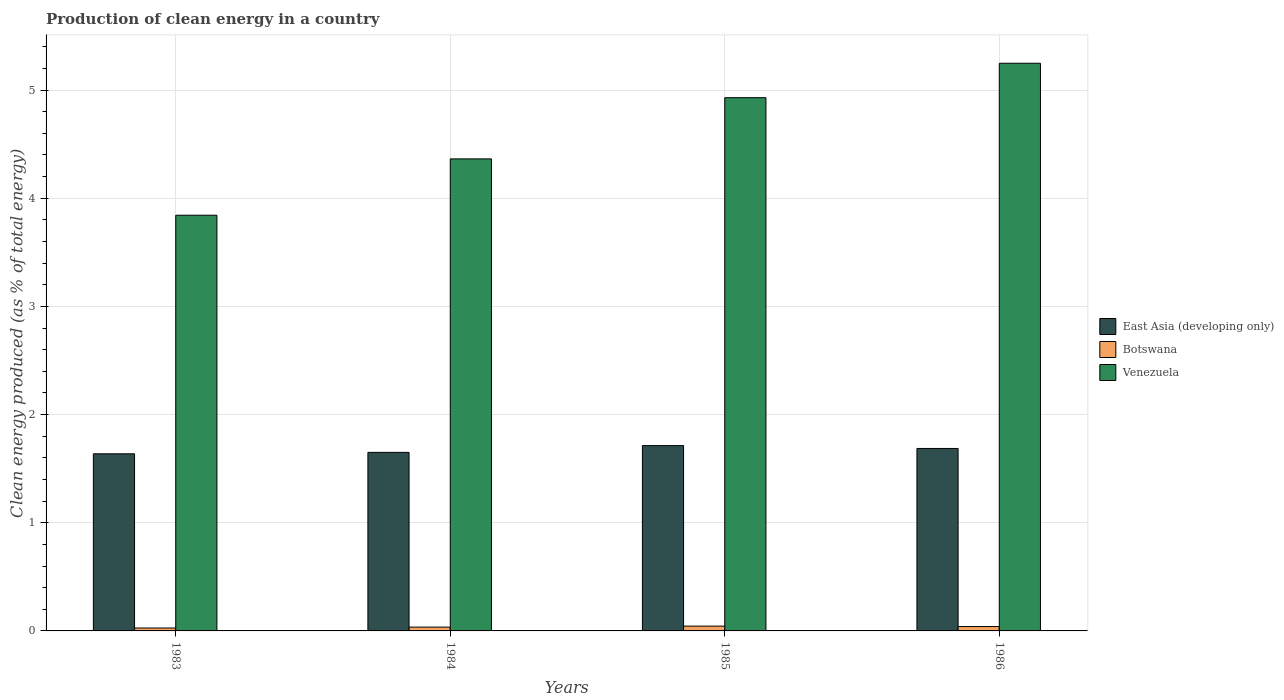How many different coloured bars are there?
Make the answer very short. 3. How many groups of bars are there?
Make the answer very short. 4. What is the label of the 3rd group of bars from the left?
Offer a terse response. 1985. In how many cases, is the number of bars for a given year not equal to the number of legend labels?
Offer a terse response. 0. What is the percentage of clean energy produced in Venezuela in 1986?
Make the answer very short. 5.25. Across all years, what is the maximum percentage of clean energy produced in East Asia (developing only)?
Your answer should be very brief. 1.71. Across all years, what is the minimum percentage of clean energy produced in Botswana?
Ensure brevity in your answer.  0.03. What is the total percentage of clean energy produced in East Asia (developing only) in the graph?
Keep it short and to the point. 6.69. What is the difference between the percentage of clean energy produced in Botswana in 1983 and that in 1985?
Offer a very short reply. -0.02. What is the difference between the percentage of clean energy produced in East Asia (developing only) in 1986 and the percentage of clean energy produced in Venezuela in 1984?
Give a very brief answer. -2.68. What is the average percentage of clean energy produced in Botswana per year?
Your response must be concise. 0.04. In the year 1986, what is the difference between the percentage of clean energy produced in Venezuela and percentage of clean energy produced in Botswana?
Your response must be concise. 5.21. In how many years, is the percentage of clean energy produced in East Asia (developing only) greater than 2.8 %?
Offer a terse response. 0. What is the ratio of the percentage of clean energy produced in East Asia (developing only) in 1984 to that in 1985?
Offer a very short reply. 0.96. Is the percentage of clean energy produced in Botswana in 1983 less than that in 1985?
Provide a short and direct response. Yes. What is the difference between the highest and the second highest percentage of clean energy produced in Venezuela?
Your answer should be compact. 0.32. What is the difference between the highest and the lowest percentage of clean energy produced in East Asia (developing only)?
Make the answer very short. 0.08. In how many years, is the percentage of clean energy produced in East Asia (developing only) greater than the average percentage of clean energy produced in East Asia (developing only) taken over all years?
Your answer should be compact. 2. Is the sum of the percentage of clean energy produced in Botswana in 1983 and 1985 greater than the maximum percentage of clean energy produced in East Asia (developing only) across all years?
Your answer should be compact. No. What does the 2nd bar from the left in 1983 represents?
Keep it short and to the point. Botswana. What does the 2nd bar from the right in 1984 represents?
Offer a very short reply. Botswana. Are all the bars in the graph horizontal?
Your response must be concise. No. How many years are there in the graph?
Offer a terse response. 4. What is the difference between two consecutive major ticks on the Y-axis?
Offer a very short reply. 1. Are the values on the major ticks of Y-axis written in scientific E-notation?
Provide a short and direct response. No. Where does the legend appear in the graph?
Your response must be concise. Center right. What is the title of the graph?
Give a very brief answer. Production of clean energy in a country. Does "Mongolia" appear as one of the legend labels in the graph?
Ensure brevity in your answer.  No. What is the label or title of the Y-axis?
Offer a terse response. Clean energy produced (as % of total energy). What is the Clean energy produced (as % of total energy) in East Asia (developing only) in 1983?
Offer a very short reply. 1.64. What is the Clean energy produced (as % of total energy) in Botswana in 1983?
Provide a short and direct response. 0.03. What is the Clean energy produced (as % of total energy) in Venezuela in 1983?
Offer a very short reply. 3.84. What is the Clean energy produced (as % of total energy) of East Asia (developing only) in 1984?
Your answer should be compact. 1.65. What is the Clean energy produced (as % of total energy) in Botswana in 1984?
Give a very brief answer. 0.04. What is the Clean energy produced (as % of total energy) in Venezuela in 1984?
Offer a terse response. 4.36. What is the Clean energy produced (as % of total energy) of East Asia (developing only) in 1985?
Ensure brevity in your answer.  1.71. What is the Clean energy produced (as % of total energy) of Botswana in 1985?
Make the answer very short. 0.04. What is the Clean energy produced (as % of total energy) of Venezuela in 1985?
Provide a short and direct response. 4.93. What is the Clean energy produced (as % of total energy) of East Asia (developing only) in 1986?
Ensure brevity in your answer.  1.69. What is the Clean energy produced (as % of total energy) in Botswana in 1986?
Offer a terse response. 0.04. What is the Clean energy produced (as % of total energy) in Venezuela in 1986?
Make the answer very short. 5.25. Across all years, what is the maximum Clean energy produced (as % of total energy) in East Asia (developing only)?
Your answer should be compact. 1.71. Across all years, what is the maximum Clean energy produced (as % of total energy) in Botswana?
Your response must be concise. 0.04. Across all years, what is the maximum Clean energy produced (as % of total energy) of Venezuela?
Your answer should be compact. 5.25. Across all years, what is the minimum Clean energy produced (as % of total energy) of East Asia (developing only)?
Your answer should be very brief. 1.64. Across all years, what is the minimum Clean energy produced (as % of total energy) of Botswana?
Your response must be concise. 0.03. Across all years, what is the minimum Clean energy produced (as % of total energy) of Venezuela?
Ensure brevity in your answer.  3.84. What is the total Clean energy produced (as % of total energy) of East Asia (developing only) in the graph?
Your answer should be very brief. 6.69. What is the total Clean energy produced (as % of total energy) of Botswana in the graph?
Your answer should be compact. 0.15. What is the total Clean energy produced (as % of total energy) of Venezuela in the graph?
Your answer should be compact. 18.38. What is the difference between the Clean energy produced (as % of total energy) of East Asia (developing only) in 1983 and that in 1984?
Your response must be concise. -0.01. What is the difference between the Clean energy produced (as % of total energy) in Botswana in 1983 and that in 1984?
Offer a very short reply. -0.01. What is the difference between the Clean energy produced (as % of total energy) in Venezuela in 1983 and that in 1984?
Keep it short and to the point. -0.52. What is the difference between the Clean energy produced (as % of total energy) in East Asia (developing only) in 1983 and that in 1985?
Make the answer very short. -0.08. What is the difference between the Clean energy produced (as % of total energy) of Botswana in 1983 and that in 1985?
Provide a succinct answer. -0.02. What is the difference between the Clean energy produced (as % of total energy) in Venezuela in 1983 and that in 1985?
Make the answer very short. -1.09. What is the difference between the Clean energy produced (as % of total energy) of East Asia (developing only) in 1983 and that in 1986?
Offer a very short reply. -0.05. What is the difference between the Clean energy produced (as % of total energy) of Botswana in 1983 and that in 1986?
Offer a terse response. -0.01. What is the difference between the Clean energy produced (as % of total energy) of Venezuela in 1983 and that in 1986?
Provide a succinct answer. -1.4. What is the difference between the Clean energy produced (as % of total energy) of East Asia (developing only) in 1984 and that in 1985?
Offer a very short reply. -0.06. What is the difference between the Clean energy produced (as % of total energy) in Botswana in 1984 and that in 1985?
Keep it short and to the point. -0.01. What is the difference between the Clean energy produced (as % of total energy) of Venezuela in 1984 and that in 1985?
Your answer should be very brief. -0.57. What is the difference between the Clean energy produced (as % of total energy) of East Asia (developing only) in 1984 and that in 1986?
Provide a short and direct response. -0.04. What is the difference between the Clean energy produced (as % of total energy) of Botswana in 1984 and that in 1986?
Your answer should be compact. -0.01. What is the difference between the Clean energy produced (as % of total energy) in Venezuela in 1984 and that in 1986?
Offer a very short reply. -0.88. What is the difference between the Clean energy produced (as % of total energy) in East Asia (developing only) in 1985 and that in 1986?
Make the answer very short. 0.03. What is the difference between the Clean energy produced (as % of total energy) in Botswana in 1985 and that in 1986?
Keep it short and to the point. 0. What is the difference between the Clean energy produced (as % of total energy) of Venezuela in 1985 and that in 1986?
Ensure brevity in your answer.  -0.32. What is the difference between the Clean energy produced (as % of total energy) of East Asia (developing only) in 1983 and the Clean energy produced (as % of total energy) of Botswana in 1984?
Provide a succinct answer. 1.6. What is the difference between the Clean energy produced (as % of total energy) of East Asia (developing only) in 1983 and the Clean energy produced (as % of total energy) of Venezuela in 1984?
Give a very brief answer. -2.73. What is the difference between the Clean energy produced (as % of total energy) in Botswana in 1983 and the Clean energy produced (as % of total energy) in Venezuela in 1984?
Your answer should be very brief. -4.34. What is the difference between the Clean energy produced (as % of total energy) of East Asia (developing only) in 1983 and the Clean energy produced (as % of total energy) of Botswana in 1985?
Your answer should be compact. 1.59. What is the difference between the Clean energy produced (as % of total energy) in East Asia (developing only) in 1983 and the Clean energy produced (as % of total energy) in Venezuela in 1985?
Provide a short and direct response. -3.29. What is the difference between the Clean energy produced (as % of total energy) of Botswana in 1983 and the Clean energy produced (as % of total energy) of Venezuela in 1985?
Keep it short and to the point. -4.9. What is the difference between the Clean energy produced (as % of total energy) in East Asia (developing only) in 1983 and the Clean energy produced (as % of total energy) in Botswana in 1986?
Ensure brevity in your answer.  1.6. What is the difference between the Clean energy produced (as % of total energy) of East Asia (developing only) in 1983 and the Clean energy produced (as % of total energy) of Venezuela in 1986?
Your answer should be very brief. -3.61. What is the difference between the Clean energy produced (as % of total energy) of Botswana in 1983 and the Clean energy produced (as % of total energy) of Venezuela in 1986?
Make the answer very short. -5.22. What is the difference between the Clean energy produced (as % of total energy) of East Asia (developing only) in 1984 and the Clean energy produced (as % of total energy) of Botswana in 1985?
Provide a short and direct response. 1.61. What is the difference between the Clean energy produced (as % of total energy) in East Asia (developing only) in 1984 and the Clean energy produced (as % of total energy) in Venezuela in 1985?
Keep it short and to the point. -3.28. What is the difference between the Clean energy produced (as % of total energy) of Botswana in 1984 and the Clean energy produced (as % of total energy) of Venezuela in 1985?
Ensure brevity in your answer.  -4.89. What is the difference between the Clean energy produced (as % of total energy) in East Asia (developing only) in 1984 and the Clean energy produced (as % of total energy) in Botswana in 1986?
Offer a terse response. 1.61. What is the difference between the Clean energy produced (as % of total energy) of East Asia (developing only) in 1984 and the Clean energy produced (as % of total energy) of Venezuela in 1986?
Give a very brief answer. -3.6. What is the difference between the Clean energy produced (as % of total energy) in Botswana in 1984 and the Clean energy produced (as % of total energy) in Venezuela in 1986?
Make the answer very short. -5.21. What is the difference between the Clean energy produced (as % of total energy) of East Asia (developing only) in 1985 and the Clean energy produced (as % of total energy) of Botswana in 1986?
Provide a short and direct response. 1.67. What is the difference between the Clean energy produced (as % of total energy) in East Asia (developing only) in 1985 and the Clean energy produced (as % of total energy) in Venezuela in 1986?
Your response must be concise. -3.53. What is the difference between the Clean energy produced (as % of total energy) in Botswana in 1985 and the Clean energy produced (as % of total energy) in Venezuela in 1986?
Give a very brief answer. -5.2. What is the average Clean energy produced (as % of total energy) in East Asia (developing only) per year?
Give a very brief answer. 1.67. What is the average Clean energy produced (as % of total energy) in Botswana per year?
Keep it short and to the point. 0.04. What is the average Clean energy produced (as % of total energy) of Venezuela per year?
Offer a very short reply. 4.6. In the year 1983, what is the difference between the Clean energy produced (as % of total energy) of East Asia (developing only) and Clean energy produced (as % of total energy) of Botswana?
Give a very brief answer. 1.61. In the year 1983, what is the difference between the Clean energy produced (as % of total energy) of East Asia (developing only) and Clean energy produced (as % of total energy) of Venezuela?
Your answer should be compact. -2.21. In the year 1983, what is the difference between the Clean energy produced (as % of total energy) of Botswana and Clean energy produced (as % of total energy) of Venezuela?
Give a very brief answer. -3.82. In the year 1984, what is the difference between the Clean energy produced (as % of total energy) in East Asia (developing only) and Clean energy produced (as % of total energy) in Botswana?
Offer a terse response. 1.62. In the year 1984, what is the difference between the Clean energy produced (as % of total energy) of East Asia (developing only) and Clean energy produced (as % of total energy) of Venezuela?
Provide a short and direct response. -2.71. In the year 1984, what is the difference between the Clean energy produced (as % of total energy) in Botswana and Clean energy produced (as % of total energy) in Venezuela?
Your answer should be very brief. -4.33. In the year 1985, what is the difference between the Clean energy produced (as % of total energy) in East Asia (developing only) and Clean energy produced (as % of total energy) in Botswana?
Provide a short and direct response. 1.67. In the year 1985, what is the difference between the Clean energy produced (as % of total energy) of East Asia (developing only) and Clean energy produced (as % of total energy) of Venezuela?
Offer a very short reply. -3.22. In the year 1985, what is the difference between the Clean energy produced (as % of total energy) in Botswana and Clean energy produced (as % of total energy) in Venezuela?
Offer a very short reply. -4.88. In the year 1986, what is the difference between the Clean energy produced (as % of total energy) of East Asia (developing only) and Clean energy produced (as % of total energy) of Botswana?
Provide a succinct answer. 1.65. In the year 1986, what is the difference between the Clean energy produced (as % of total energy) of East Asia (developing only) and Clean energy produced (as % of total energy) of Venezuela?
Your answer should be very brief. -3.56. In the year 1986, what is the difference between the Clean energy produced (as % of total energy) in Botswana and Clean energy produced (as % of total energy) in Venezuela?
Offer a terse response. -5.21. What is the ratio of the Clean energy produced (as % of total energy) in East Asia (developing only) in 1983 to that in 1984?
Provide a short and direct response. 0.99. What is the ratio of the Clean energy produced (as % of total energy) of Botswana in 1983 to that in 1984?
Make the answer very short. 0.76. What is the ratio of the Clean energy produced (as % of total energy) of Venezuela in 1983 to that in 1984?
Your response must be concise. 0.88. What is the ratio of the Clean energy produced (as % of total energy) of East Asia (developing only) in 1983 to that in 1985?
Ensure brevity in your answer.  0.96. What is the ratio of the Clean energy produced (as % of total energy) in Botswana in 1983 to that in 1985?
Your response must be concise. 0.61. What is the ratio of the Clean energy produced (as % of total energy) of Venezuela in 1983 to that in 1985?
Keep it short and to the point. 0.78. What is the ratio of the Clean energy produced (as % of total energy) of East Asia (developing only) in 1983 to that in 1986?
Provide a short and direct response. 0.97. What is the ratio of the Clean energy produced (as % of total energy) in Botswana in 1983 to that in 1986?
Ensure brevity in your answer.  0.66. What is the ratio of the Clean energy produced (as % of total energy) of Venezuela in 1983 to that in 1986?
Your answer should be compact. 0.73. What is the ratio of the Clean energy produced (as % of total energy) of East Asia (developing only) in 1984 to that in 1985?
Provide a succinct answer. 0.96. What is the ratio of the Clean energy produced (as % of total energy) in Botswana in 1984 to that in 1985?
Your response must be concise. 0.79. What is the ratio of the Clean energy produced (as % of total energy) of Venezuela in 1984 to that in 1985?
Make the answer very short. 0.89. What is the ratio of the Clean energy produced (as % of total energy) of East Asia (developing only) in 1984 to that in 1986?
Your response must be concise. 0.98. What is the ratio of the Clean energy produced (as % of total energy) in Botswana in 1984 to that in 1986?
Your response must be concise. 0.87. What is the ratio of the Clean energy produced (as % of total energy) of Venezuela in 1984 to that in 1986?
Make the answer very short. 0.83. What is the ratio of the Clean energy produced (as % of total energy) in East Asia (developing only) in 1985 to that in 1986?
Your response must be concise. 1.02. What is the ratio of the Clean energy produced (as % of total energy) in Botswana in 1985 to that in 1986?
Ensure brevity in your answer.  1.1. What is the ratio of the Clean energy produced (as % of total energy) in Venezuela in 1985 to that in 1986?
Provide a succinct answer. 0.94. What is the difference between the highest and the second highest Clean energy produced (as % of total energy) of East Asia (developing only)?
Your response must be concise. 0.03. What is the difference between the highest and the second highest Clean energy produced (as % of total energy) in Botswana?
Make the answer very short. 0. What is the difference between the highest and the second highest Clean energy produced (as % of total energy) of Venezuela?
Keep it short and to the point. 0.32. What is the difference between the highest and the lowest Clean energy produced (as % of total energy) in East Asia (developing only)?
Provide a succinct answer. 0.08. What is the difference between the highest and the lowest Clean energy produced (as % of total energy) of Botswana?
Offer a very short reply. 0.02. What is the difference between the highest and the lowest Clean energy produced (as % of total energy) in Venezuela?
Offer a very short reply. 1.4. 